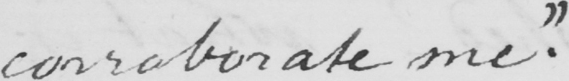What is written in this line of handwriting? corroborate me "  . 